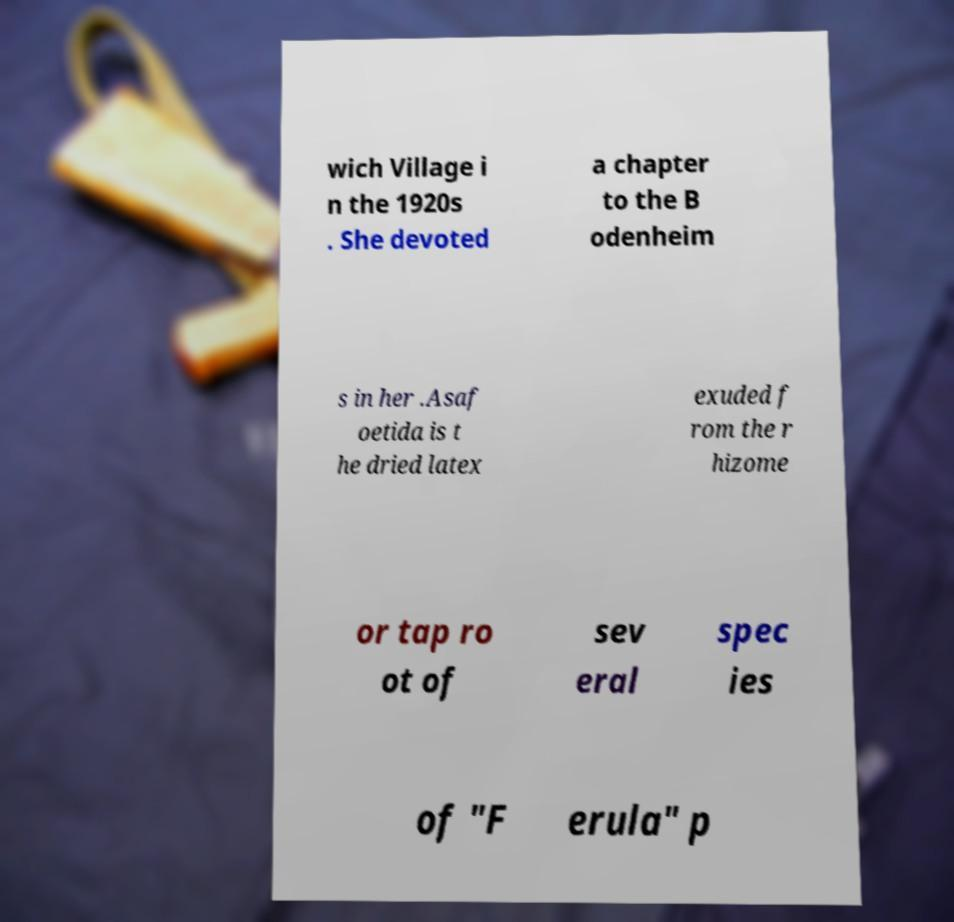Please read and relay the text visible in this image. What does it say? wich Village i n the 1920s . She devoted a chapter to the B odenheim s in her .Asaf oetida is t he dried latex exuded f rom the r hizome or tap ro ot of sev eral spec ies of "F erula" p 